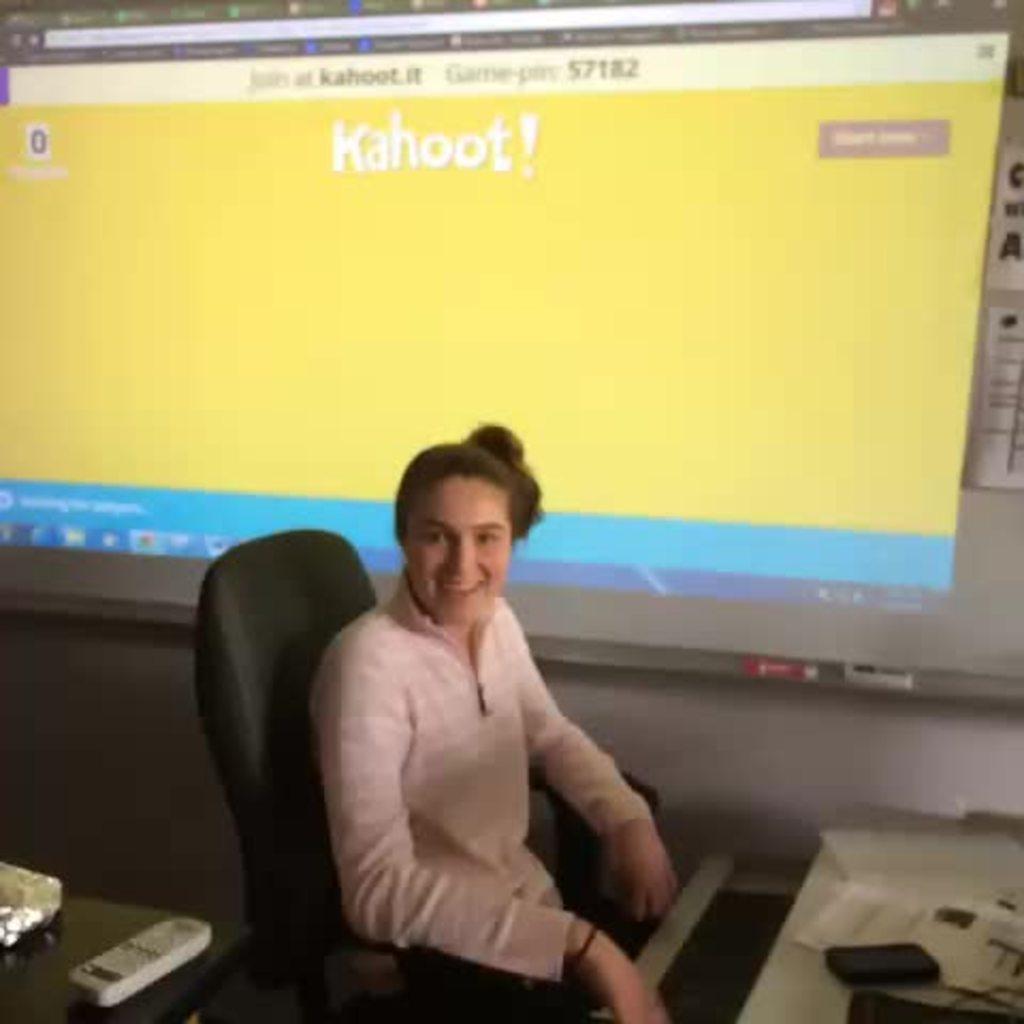Please provide a concise description of this image. In the picture we can see a woman sitting on the chair near the desk in the office, on the desk, we can see mobile phone, some papers and in the background we can see a wall with a screen and something projected in that. 